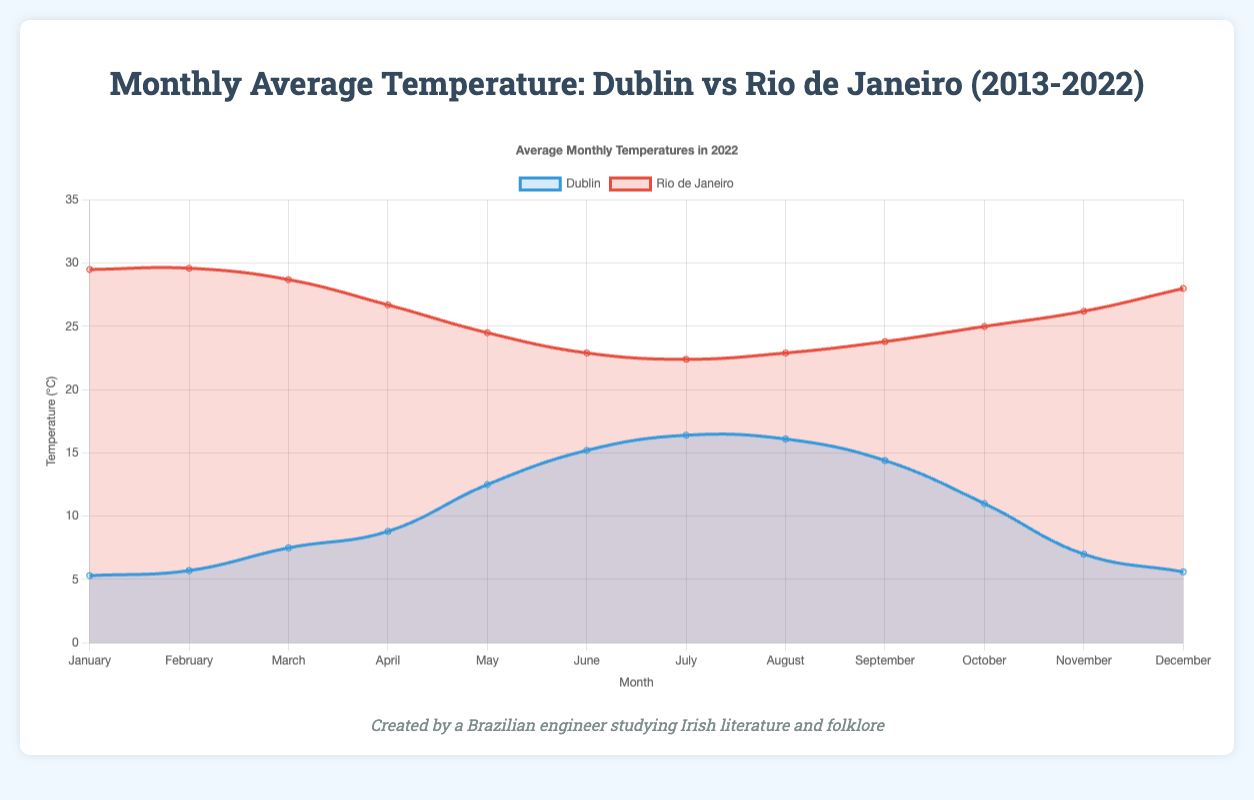What is the average temperature difference between January in Dublin and Rio de Janeiro in 2022? The temperature in Dublin in January 2022 is 5.3°C, and in Rio de Janeiro, it is 29.5°C. The difference is 29.5°C - 5.3°C = 24.2°C.
Answer: 24.2°C Which city has a higher average temperature in June 2022 and by how much? Dublin's average temperature in June 2022 is 15.2°C, and Rio de Janeiro's is 22.9°C. Comparing both, 22.9°C (Rio) - 15.2°C (Dublin) = 7.7°C.
Answer: Rio de Janeiro by 7.7°C What is the maximum average monthly temperature recorded in Dublin in 2022? Observing the line chart, Dublin's highest average monthly temperature is in July 2022 with 16.4°C.
Answer: 16.4°C In which month is the temperature difference between Dublin and Rio de Janeiro the smallest in 2022, and what is the value? Based on the chart, October shows Dublin at 11.0°C and Rio de Janeiro at 25.0°C. The difference is 25.0°C - 11.0°C = 14.0°C, which is the smallest.
Answer: October, 14.0°C How many months in 2022 did Rio de Janeiro experience an average temperature above 25°C? Referring to the chart, the months with temperatures above 25°C in Rio de Janeiro are January, February, March, November, and December. This sums up to 5 months.
Answer: 5 months Which month shows the highest average temperature change between 2013 and 2022 for Dublin? Analyzing the data points for each month over the 10 years, May shows an increase from 12.0°C in 2013 to 12.5°C in 2022. This is a change of 0.5°C, the largest among all months.
Answer: May Compare the average temperatures of Dublin across all months in 2022 and identify which month had the closest temperature to 10°C. The chart shows October with an average temperature of 11.0°C in Dublin, which is closest to 10°C.
Answer: October What is the overall trend in temperature for Dublin from June to August in 2022? Observing the chart, Dublin's temperature goes from 15.2°C in June, to 16.4°C in July, and then slightly drops to 16.1°C in August. The trend is an initial increase followed by a slight decrease.
Answer: Increase then decrease By how much does the temperature in Rio de Janeiro in July 2022 exceed the temperature in Dublin in the same month? Rio de Janeiro has 22.4°C and Dublin has 16.4°C in July 2022. The difference is 22.4°C - 16.4°C = 6.0°C.
Answer: 6.0°C 